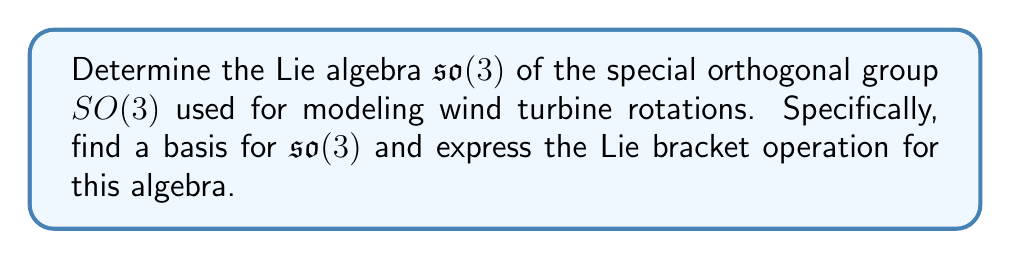What is the answer to this math problem? To determine the Lie algebra $\mathfrak{so}(3)$ of $SO(3)$, we follow these steps:

1) Recall that $SO(3)$ consists of $3 \times 3$ orthogonal matrices with determinant 1:

   $SO(3) = \{R \in \mathbb{R}^{3\times3} : R^TR = I, \det(R) = 1\}$

2) The Lie algebra $\mathfrak{so}(3)$ consists of the tangent space at the identity matrix. These are matrices $X$ such that $e^{tX} \in SO(3)$ for all real $t$.

3) Differentiating the orthogonality condition $R^TR = I$ at $t=0$ gives:

   $X^T + X = 0$

   This means $X$ must be a $3 \times 3$ skew-symmetric matrix.

4) The general form of a $3 \times 3$ skew-symmetric matrix is:

   $$X = \begin{pmatrix}
   0 & -c & b \\
   c & 0 & -a \\
   -b & a & 0
   \end{pmatrix}$$

5) We can choose a basis for $\mathfrak{so}(3)$ as:

   $$E_1 = \begin{pmatrix}
   0 & 0 & 0 \\
   0 & 0 & -1 \\
   0 & 1 & 0
   \end{pmatrix}, \
   E_2 = \begin{pmatrix}
   0 & 0 & 1 \\
   0 & 0 & 0 \\
   -1 & 0 & 0
   \end{pmatrix}, \
   E_3 = \begin{pmatrix}
   0 & -1 & 0 \\
   1 & 0 & 0 \\
   0 & 0 & 0
   \end{pmatrix}$$

6) The Lie bracket operation for $\mathfrak{so}(3)$ is given by the matrix commutator:

   $[X, Y] = XY - YX$

7) Computing the Lie brackets of the basis elements:

   $[E_1, E_2] = E_3$
   $[E_2, E_3] = E_1$
   $[E_3, E_1] = E_2$

These relations define the structure of $\mathfrak{so}(3)$ as a Lie algebra.
Answer: The Lie algebra $\mathfrak{so}(3)$ consists of $3 \times 3$ skew-symmetric matrices. A basis for $\mathfrak{so}(3)$ is:

$$E_1 = \begin{pmatrix}
0 & 0 & 0 \\
0 & 0 & -1 \\
0 & 1 & 0
\end{pmatrix}, \
E_2 = \begin{pmatrix}
0 & 0 & 1 \\
0 & 0 & 0 \\
-1 & 0 & 0
\end{pmatrix}, \
E_3 = \begin{pmatrix}
0 & -1 & 0 \\
1 & 0 & 0 \\
0 & 0 & 0
\end{pmatrix}$$

The Lie bracket operation is $[X, Y] = XY - YX$, with $[E_1, E_2] = E_3$, $[E_2, E_3] = E_1$, $[E_3, E_1] = E_2$. 